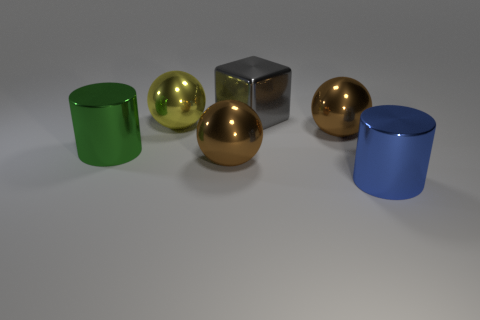Subtract all cyan cubes. Subtract all yellow cylinders. How many cubes are left? 1 Add 2 rubber balls. How many objects exist? 8 Subtract all cubes. How many objects are left? 5 Subtract all brown balls. Subtract all big blue cylinders. How many objects are left? 3 Add 2 shiny cylinders. How many shiny cylinders are left? 4 Add 1 purple metal blocks. How many purple metal blocks exist? 1 Subtract 0 cyan spheres. How many objects are left? 6 